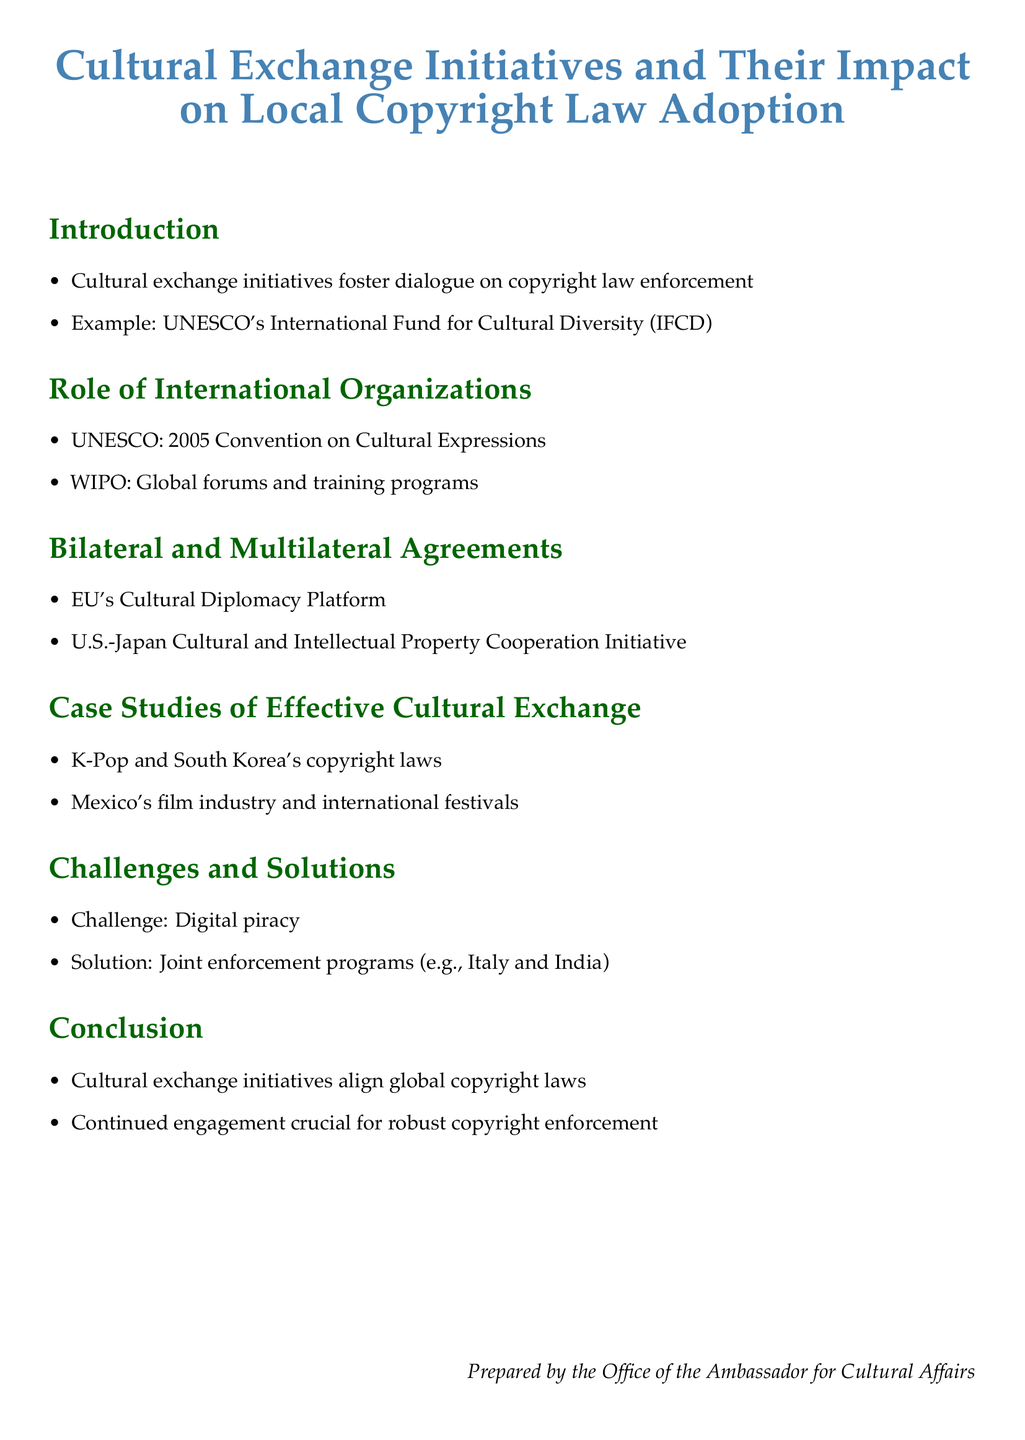What is the title of the document? The title of the document is prominently displayed at the top, stating the focus on cultural exchange initiatives and copyright law adoption.
Answer: Cultural Exchange Initiatives and Their Impact on Local Copyright Law Adoption Which organization is mentioned in relation to the 2005 Convention on Cultural Expressions? The document lists UNESCO as the organization associated with this convention, highlighting its role in cultural affairs.
Answer: UNESCO What is one example of a cultural exchange initiative provided in the document? The document mentions UNESCO's International Fund for Cultural Diversity (IFCD) as an example of a cultural exchange initiative that promotes dialogue on copyright law enforcement.
Answer: UNESCO's International Fund for Cultural Diversity What challenge related to copyright is discussed in the document? The document specifies that digital piracy is a challenge faced in the context of copyright enforcement.
Answer: Digital piracy Which two countries are mentioned as having joint enforcement programs? The document identifies Italy and India as countries that have initiated joint enforcement programs to combat challenges such as digital piracy.
Answer: Italy and India In which sector is the impact of K-Pop highlighted? The document discusses K-Pop in relation to South Korea's copyright laws, illustrating how cultural exchange has influenced local legislation.
Answer: South Korea's copyright laws What is the conclusion focused on regarding cultural exchange initiatives? The conclusion emphasizes that cultural exchange initiatives align global copyright laws and highlight the importance of continued engagement for robust enforcement.
Answer: Align global copyright laws Which multilateral agreement is discussed in the document? The document refers to the EU's Cultural Diplomacy Platform as a significant multilateral agreement that promotes cultural exchange.
Answer: EU's Cultural Diplomacy Platform 